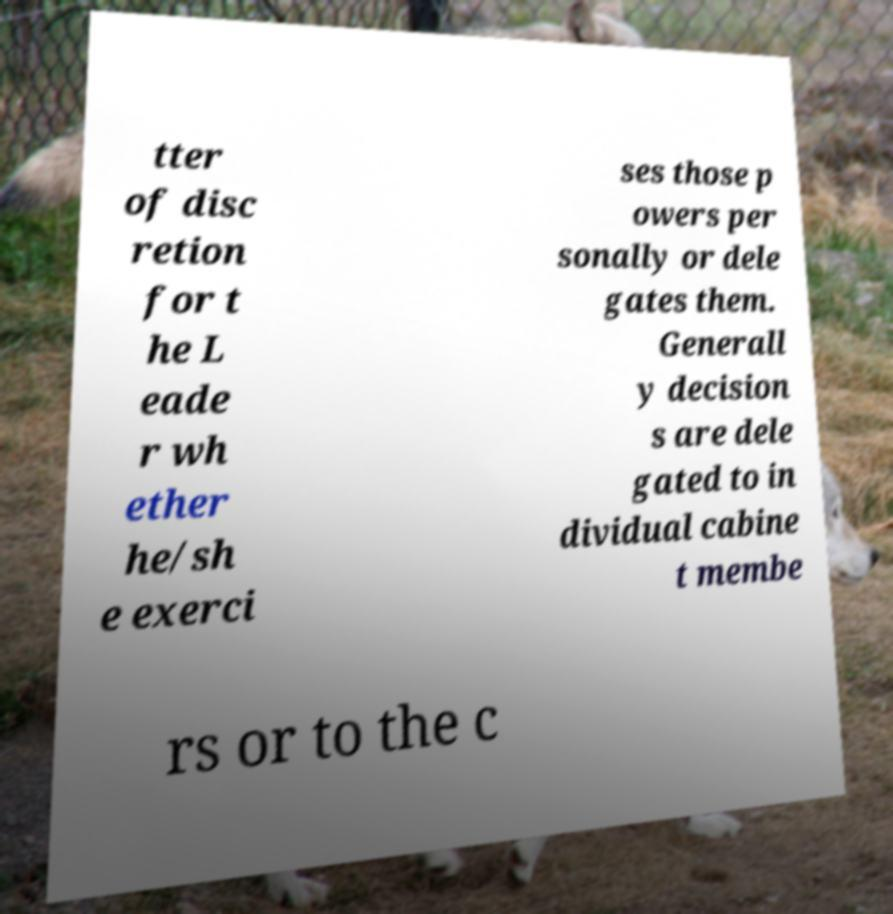I need the written content from this picture converted into text. Can you do that? tter of disc retion for t he L eade r wh ether he/sh e exerci ses those p owers per sonally or dele gates them. Generall y decision s are dele gated to in dividual cabine t membe rs or to the c 